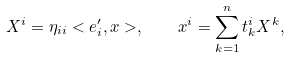<formula> <loc_0><loc_0><loc_500><loc_500>X ^ { i } = \eta _ { i i } < e _ { i } ^ { \prime } , x > , \quad x ^ { i } = \sum _ { k = 1 } ^ { n } t _ { k } ^ { i } X ^ { k } ,</formula> 